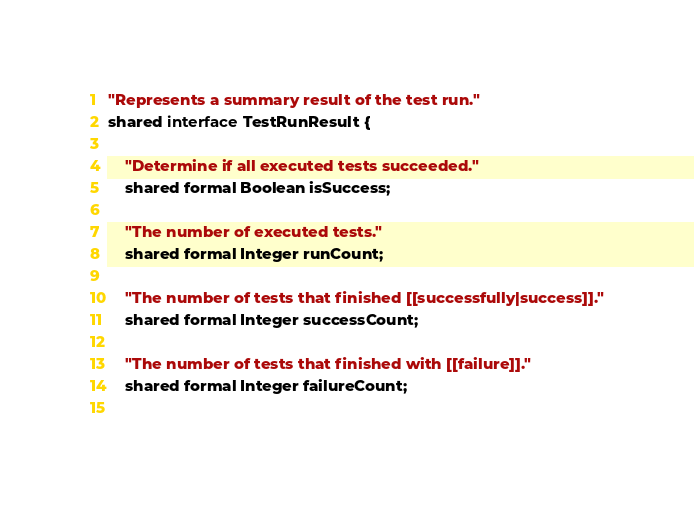<code> <loc_0><loc_0><loc_500><loc_500><_Ceylon_>"Represents a summary result of the test run."
shared interface TestRunResult {
    
    "Determine if all executed tests succeeded."
    shared formal Boolean isSuccess;
    
    "The number of executed tests."
    shared formal Integer runCount;
    
    "The number of tests that finished [[successfully|success]]."
    shared formal Integer successCount;
    
    "The number of tests that finished with [[failure]]."
    shared formal Integer failureCount;
    </code> 